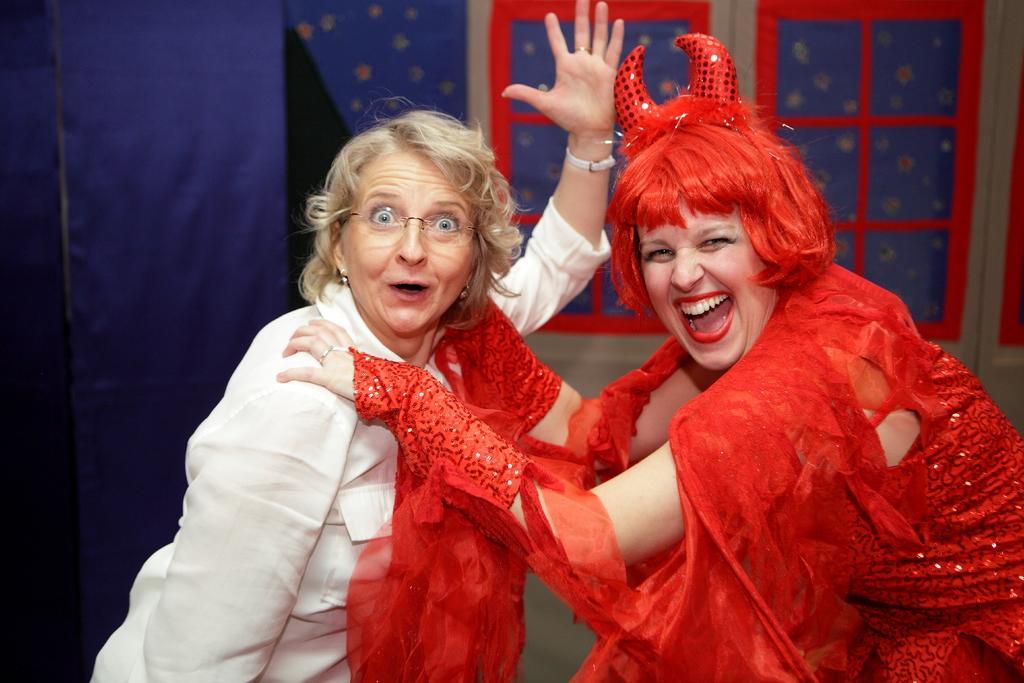Can you describe this image briefly? In this image we can see two people. And one person is wearing a different costume. And in the background, we can see the curtain and the windows. 